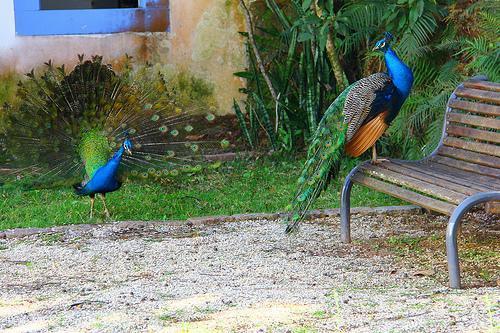How many peacocks are on the bench?
Give a very brief answer. 1. How many birds are in the photo?
Give a very brief answer. 2. 